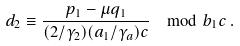<formula> <loc_0><loc_0><loc_500><loc_500>d _ { 2 } \equiv \frac { p _ { 1 } - \mu q _ { 1 } } { ( 2 / \gamma _ { 2 } ) ( a _ { 1 } / \gamma _ { a } ) c } \mod b _ { 1 } c \, .</formula> 